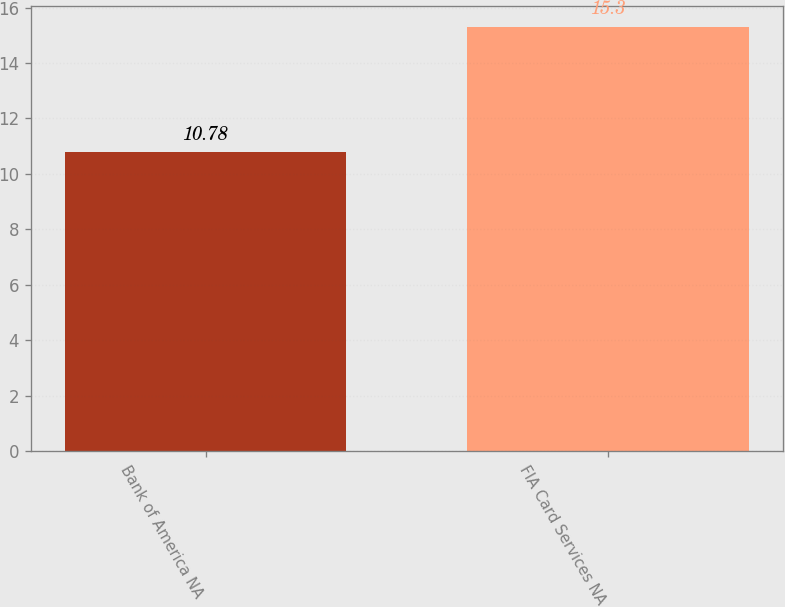<chart> <loc_0><loc_0><loc_500><loc_500><bar_chart><fcel>Bank of America NA<fcel>FIA Card Services NA<nl><fcel>10.78<fcel>15.3<nl></chart> 